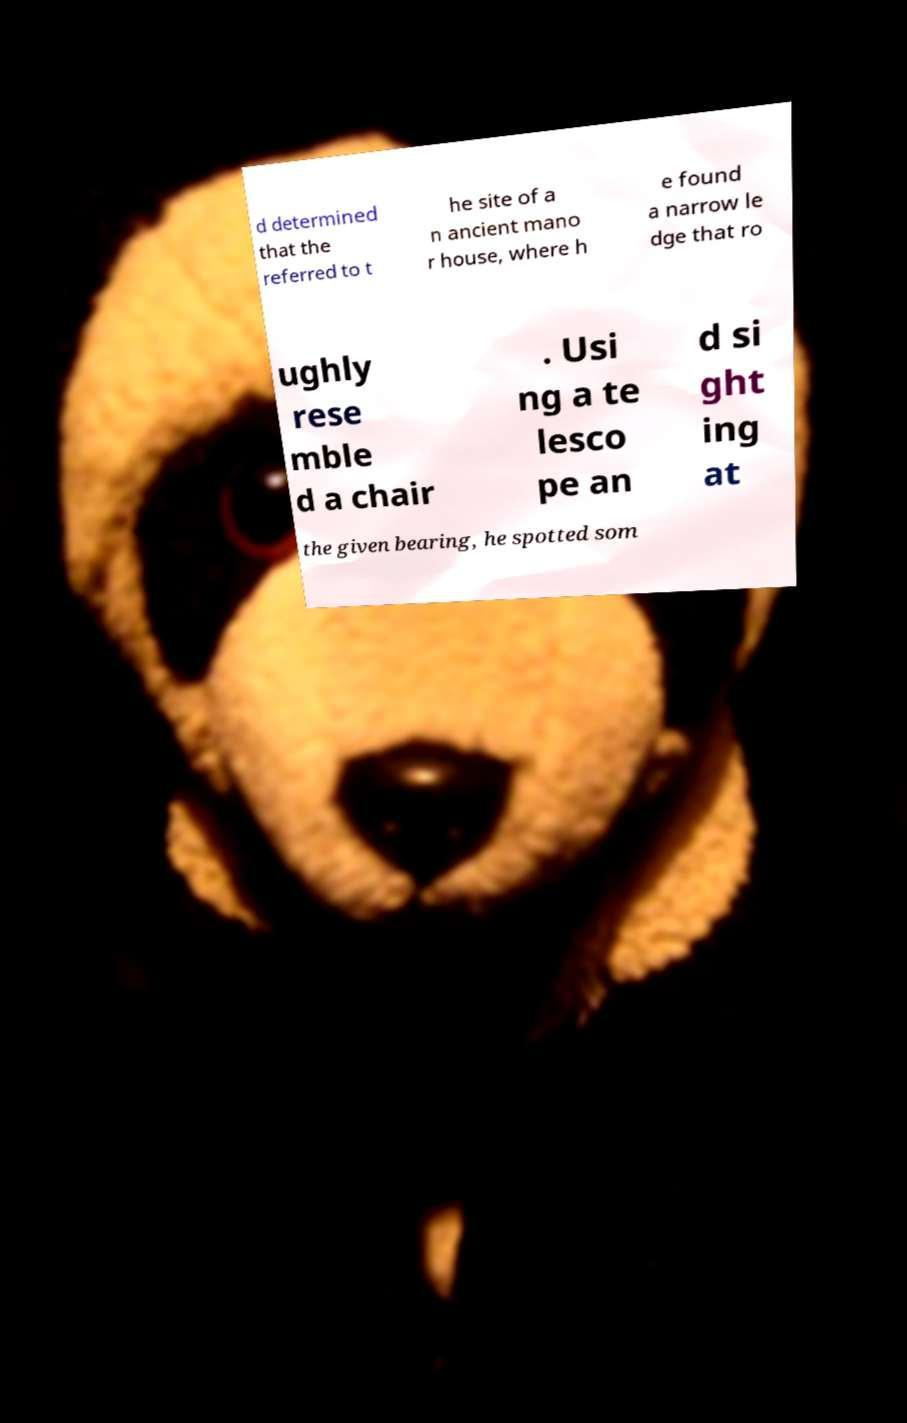Can you read and provide the text displayed in the image?This photo seems to have some interesting text. Can you extract and type it out for me? d determined that the referred to t he site of a n ancient mano r house, where h e found a narrow le dge that ro ughly rese mble d a chair . Usi ng a te lesco pe an d si ght ing at the given bearing, he spotted som 